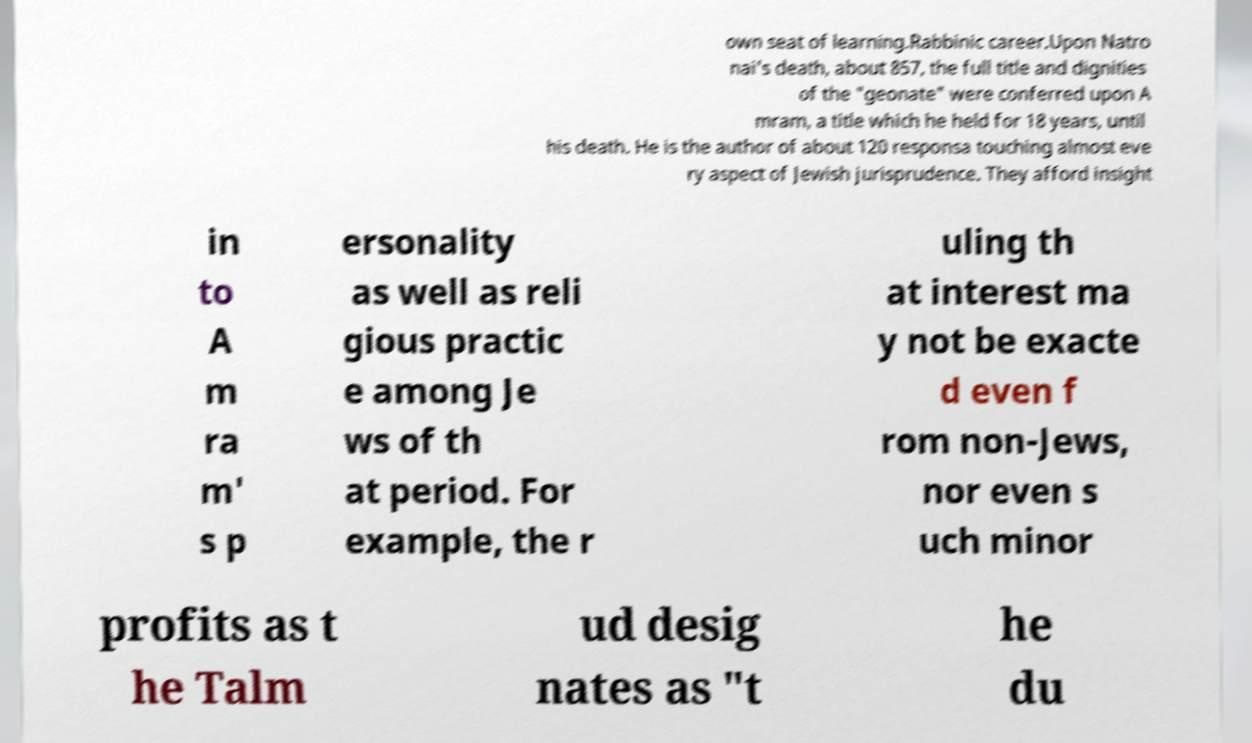Could you extract and type out the text from this image? own seat of learning.Rabbinic career.Upon Natro nai's death, about 857, the full title and dignities of the "geonate" were conferred upon A mram, a title which he held for 18 years, until his death. He is the author of about 120 responsa touching almost eve ry aspect of Jewish jurisprudence. They afford insight in to A m ra m' s p ersonality as well as reli gious practic e among Je ws of th at period. For example, the r uling th at interest ma y not be exacte d even f rom non-Jews, nor even s uch minor profits as t he Talm ud desig nates as "t he du 